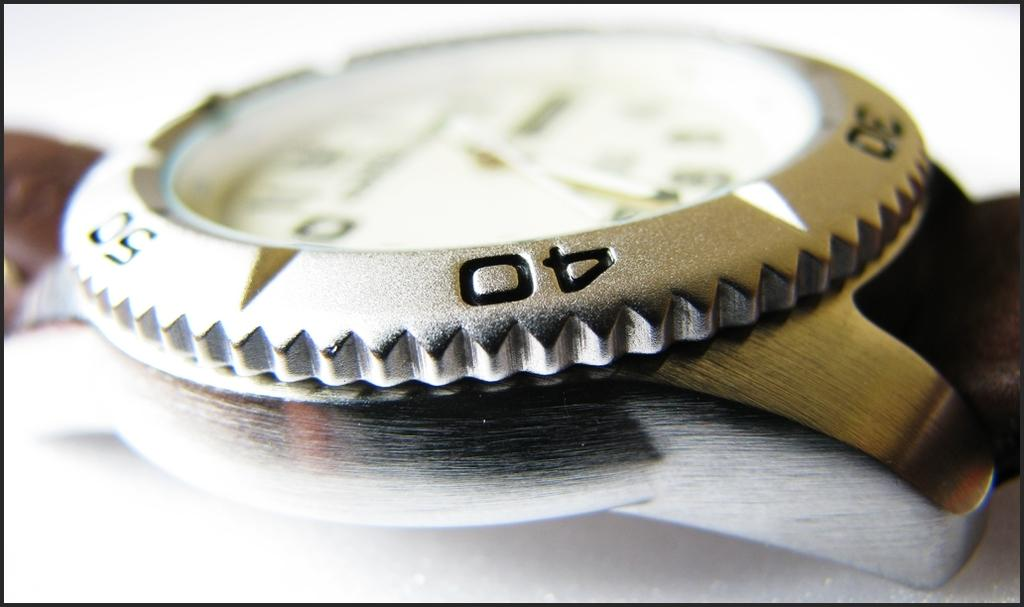<image>
Describe the image concisely. A watch which has numbers including 30 and 40 on it. 